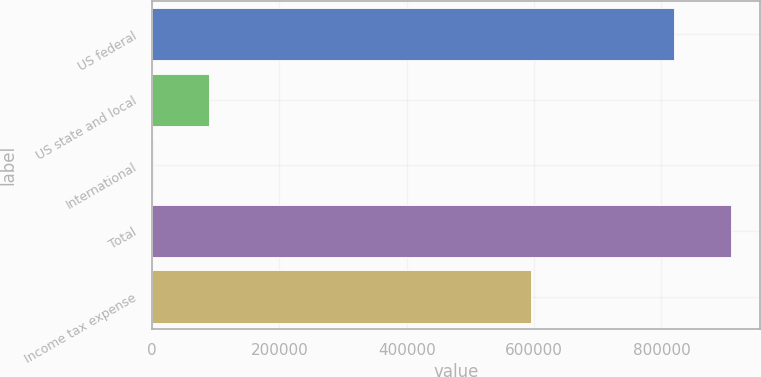Convert chart. <chart><loc_0><loc_0><loc_500><loc_500><bar_chart><fcel>US federal<fcel>US state and local<fcel>International<fcel>Total<fcel>Income tax expense<nl><fcel>820180<fcel>89694.6<fcel>907<fcel>908968<fcel>594692<nl></chart> 